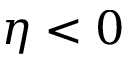Convert formula to latex. <formula><loc_0><loc_0><loc_500><loc_500>\eta < 0</formula> 